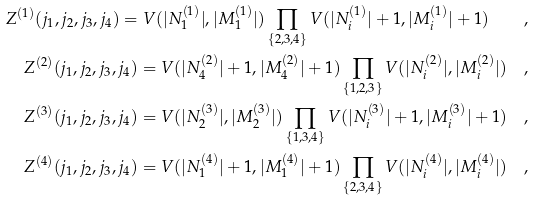<formula> <loc_0><loc_0><loc_500><loc_500>Z ^ { ( 1 ) } ( j _ { 1 } , j _ { 2 } , j _ { 3 } , j _ { 4 } ) = V ( | N _ { 1 } ^ { ( 1 ) } | , | M _ { 1 } ^ { ( 1 ) } | ) \prod _ { \{ 2 , 3 , 4 \} } V ( | N _ { i } ^ { ( 1 ) } | + 1 , | M _ { i } ^ { ( 1 ) } | + 1 ) \quad , \\ Z ^ { ( 2 ) } ( j _ { 1 } , j _ { 2 } , j _ { 3 } , j _ { 4 } ) = V ( | N _ { 4 } ^ { ( 2 ) } | + 1 , | M _ { 4 } ^ { ( 2 ) } | + 1 ) \prod _ { \{ 1 , 2 , 3 \} } V ( | N _ { i } ^ { ( 2 ) } | , | M _ { i } ^ { ( 2 ) } | ) \quad , \\ Z ^ { ( 3 ) } ( j _ { 1 } , j _ { 2 } , j _ { 3 } , j _ { 4 } ) = V ( | N _ { 2 } ^ { ( 3 ) } | , | M _ { 2 } ^ { ( 3 ) } | ) \prod _ { \{ 1 , 3 , 4 \} } V ( | N _ { i } ^ { ( 3 ) } | + 1 , | M _ { i } ^ { ( 3 ) } | + 1 ) \quad , \\ Z ^ { ( 4 ) } ( j _ { 1 } , j _ { 2 } , j _ { 3 } , j _ { 4 } ) = V ( | N _ { 1 } ^ { ( 4 ) } | + 1 , | M _ { 1 } ^ { ( 4 ) } | + 1 ) \prod _ { \{ 2 , 3 , 4 \} } V ( | N _ { i } ^ { ( 4 ) } | , | M _ { i } ^ { ( 4 ) } | ) \quad ,</formula> 